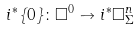Convert formula to latex. <formula><loc_0><loc_0><loc_500><loc_500>i ^ { \ast } \{ 0 \} \colon \square ^ { 0 } \to i ^ { \ast } \square _ { \Sigma } ^ { n }</formula> 